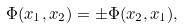Convert formula to latex. <formula><loc_0><loc_0><loc_500><loc_500>\Phi ( x _ { 1 } , x _ { 2 } ) = \pm \Phi ( x _ { 2 } , x _ { 1 } ) ,</formula> 